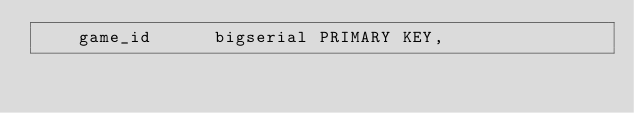<code> <loc_0><loc_0><loc_500><loc_500><_SQL_>    game_id      bigserial PRIMARY KEY,</code> 